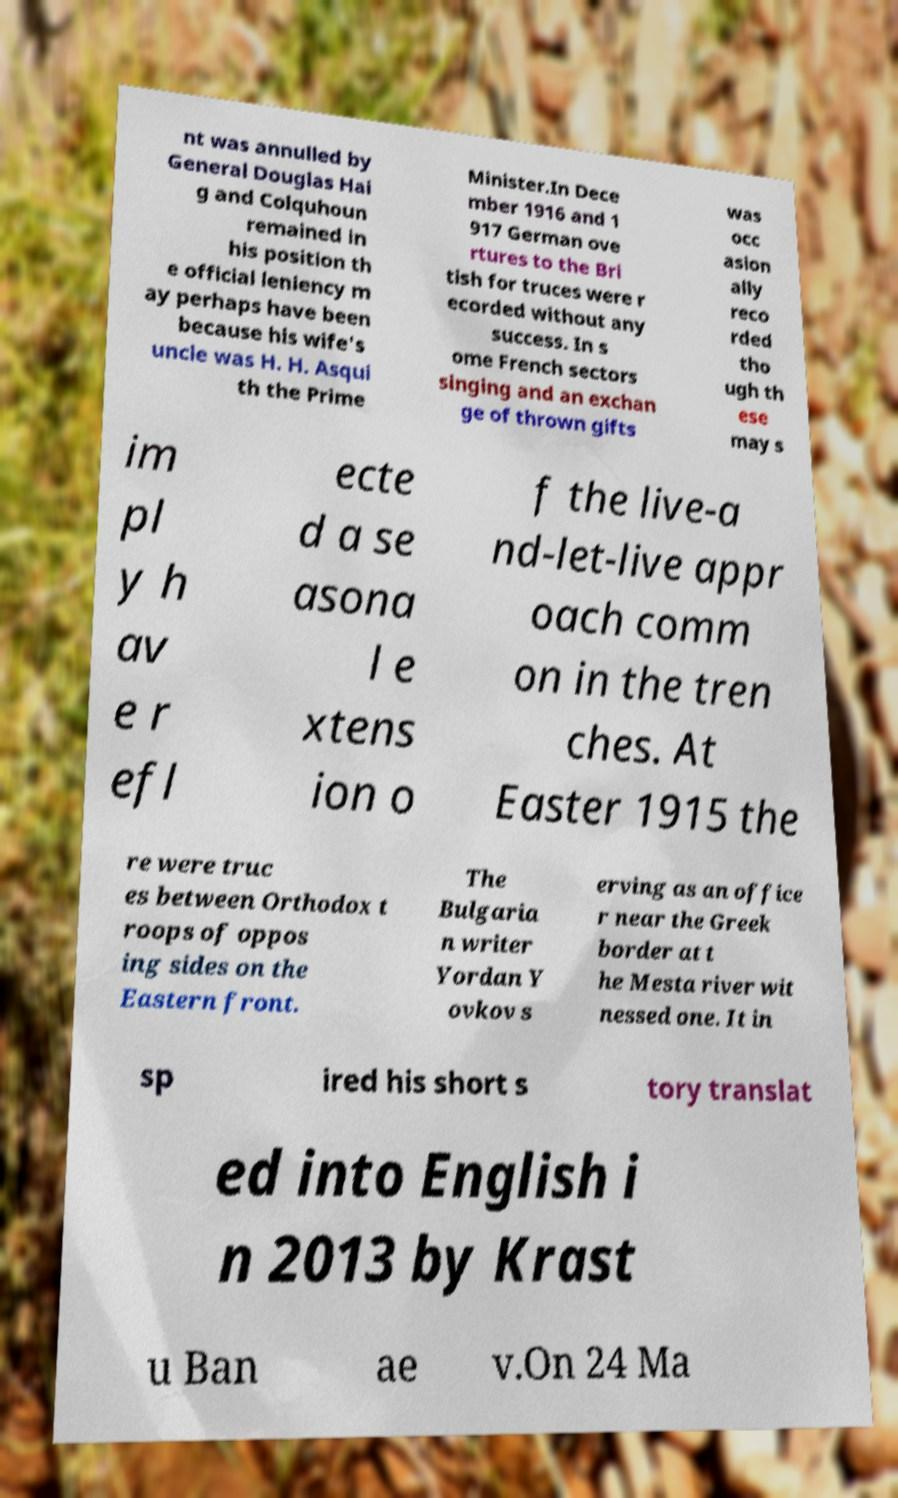Could you extract and type out the text from this image? nt was annulled by General Douglas Hai g and Colquhoun remained in his position th e official leniency m ay perhaps have been because his wife's uncle was H. H. Asqui th the Prime Minister.In Dece mber 1916 and 1 917 German ove rtures to the Bri tish for truces were r ecorded without any success. In s ome French sectors singing and an exchan ge of thrown gifts was occ asion ally reco rded tho ugh th ese may s im pl y h av e r efl ecte d a se asona l e xtens ion o f the live-a nd-let-live appr oach comm on in the tren ches. At Easter 1915 the re were truc es between Orthodox t roops of oppos ing sides on the Eastern front. The Bulgaria n writer Yordan Y ovkov s erving as an office r near the Greek border at t he Mesta river wit nessed one. It in sp ired his short s tory translat ed into English i n 2013 by Krast u Ban ae v.On 24 Ma 